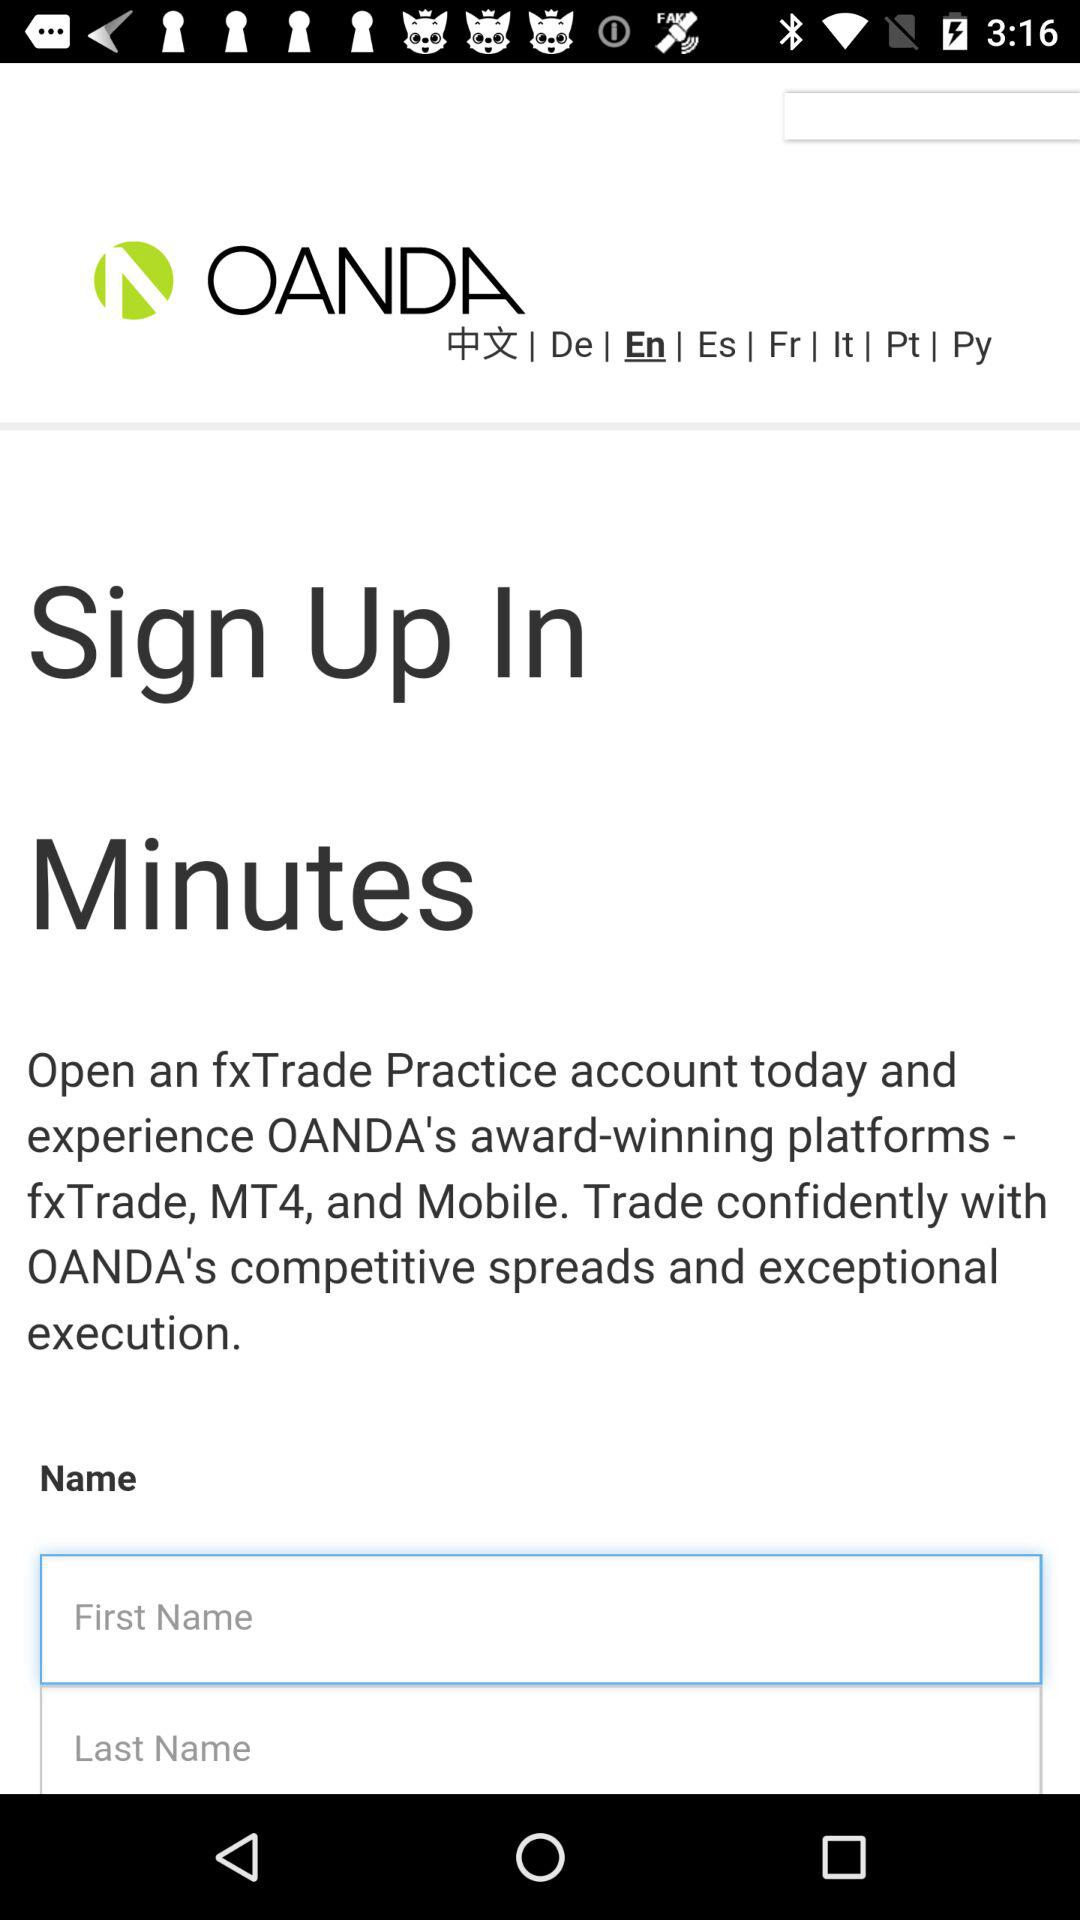How many text inputs are there for the user to enter their name? There are two text inputs for the user to enter their name; one for the first name and one for the last name, facilitating a structured form entry. 